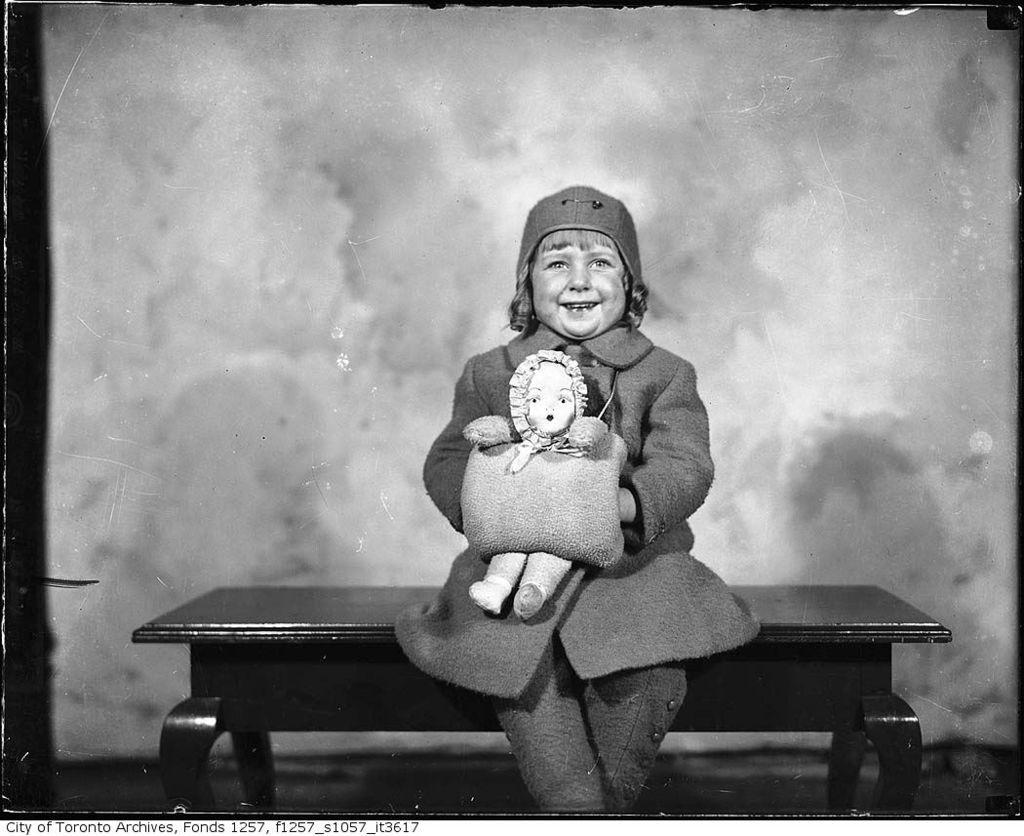Please provide a concise description of this image. Here in this picture we can see a child sitting on a table and we can see she is wearing a jacket and a cap on her and smiling and she is also holding a toy in her hand over there. 